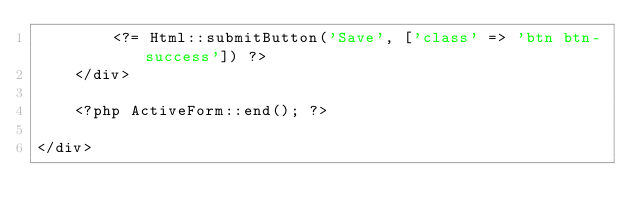Convert code to text. <code><loc_0><loc_0><loc_500><loc_500><_PHP_>        <?= Html::submitButton('Save', ['class' => 'btn btn-success']) ?>
    </div>

    <?php ActiveForm::end(); ?>

</div>
</code> 